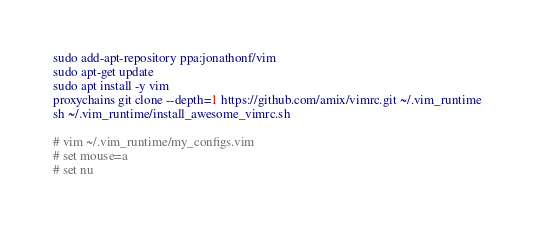Convert code to text. <code><loc_0><loc_0><loc_500><loc_500><_Bash_>sudo add-apt-repository ppa:jonathonf/vim
sudo apt-get update
sudo apt install -y vim
proxychains git clone --depth=1 https://github.com/amix/vimrc.git ~/.vim_runtime
sh ~/.vim_runtime/install_awesome_vimrc.sh

# vim ~/.vim_runtime/my_configs.vim
# set mouse=a
# set nu
</code> 